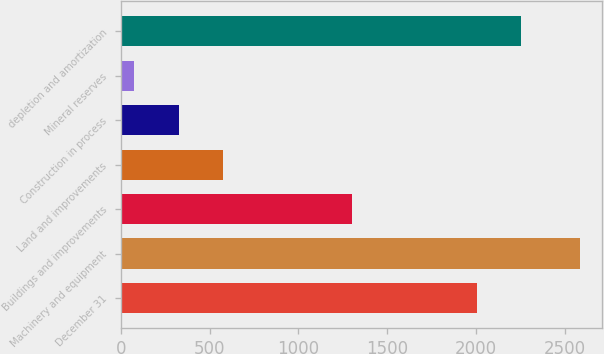Convert chart. <chart><loc_0><loc_0><loc_500><loc_500><bar_chart><fcel>December 31<fcel>Machinery and equipment<fcel>Buildings and improvements<fcel>Land and improvements<fcel>Construction in process<fcel>Mineral reserves<fcel>depletion and amortization<nl><fcel>2005<fcel>2583<fcel>1303<fcel>576.6<fcel>325.8<fcel>75<fcel>2255.8<nl></chart> 